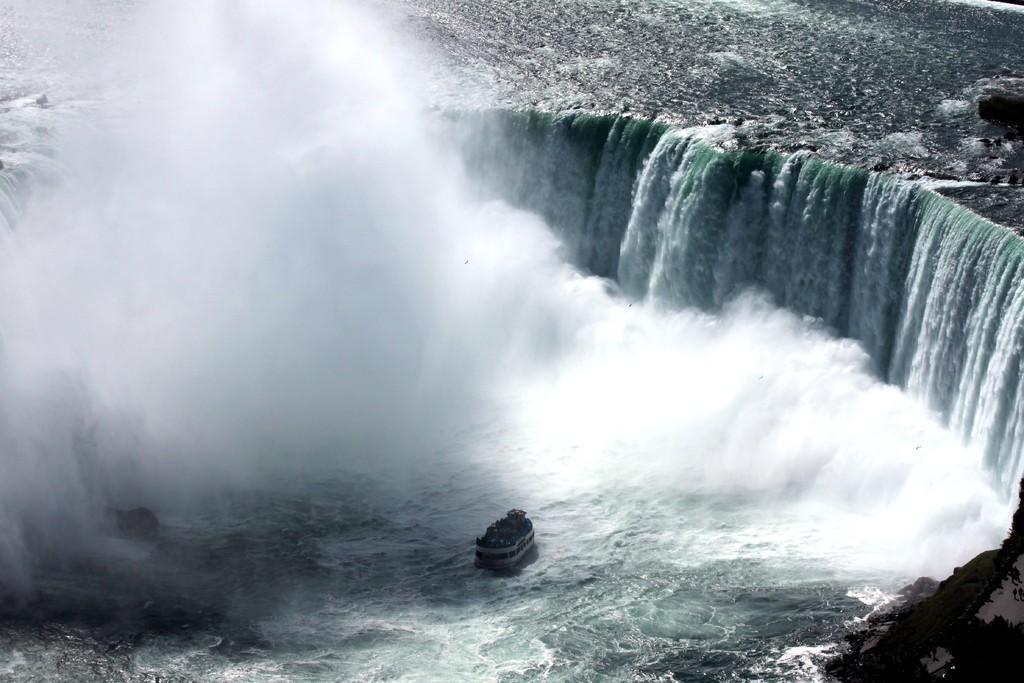How would you summarize this image in a sentence or two? In this image we can see a ship on the water and waterfalls in the background. 